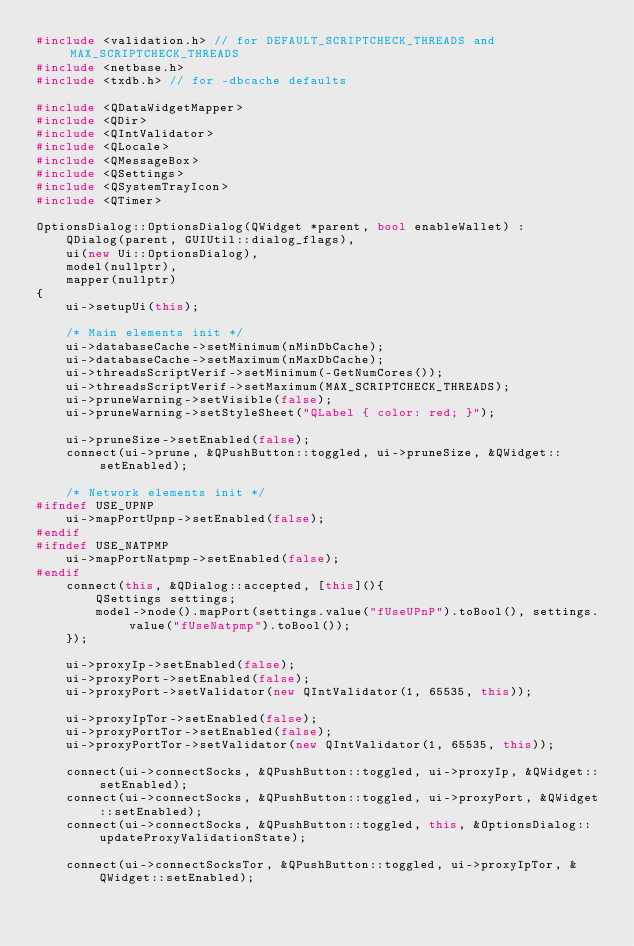<code> <loc_0><loc_0><loc_500><loc_500><_C++_>#include <validation.h> // for DEFAULT_SCRIPTCHECK_THREADS and MAX_SCRIPTCHECK_THREADS
#include <netbase.h>
#include <txdb.h> // for -dbcache defaults

#include <QDataWidgetMapper>
#include <QDir>
#include <QIntValidator>
#include <QLocale>
#include <QMessageBox>
#include <QSettings>
#include <QSystemTrayIcon>
#include <QTimer>

OptionsDialog::OptionsDialog(QWidget *parent, bool enableWallet) :
    QDialog(parent, GUIUtil::dialog_flags),
    ui(new Ui::OptionsDialog),
    model(nullptr),
    mapper(nullptr)
{
    ui->setupUi(this);

    /* Main elements init */
    ui->databaseCache->setMinimum(nMinDbCache);
    ui->databaseCache->setMaximum(nMaxDbCache);
    ui->threadsScriptVerif->setMinimum(-GetNumCores());
    ui->threadsScriptVerif->setMaximum(MAX_SCRIPTCHECK_THREADS);
    ui->pruneWarning->setVisible(false);
    ui->pruneWarning->setStyleSheet("QLabel { color: red; }");

    ui->pruneSize->setEnabled(false);
    connect(ui->prune, &QPushButton::toggled, ui->pruneSize, &QWidget::setEnabled);

    /* Network elements init */
#ifndef USE_UPNP
    ui->mapPortUpnp->setEnabled(false);
#endif
#ifndef USE_NATPMP
    ui->mapPortNatpmp->setEnabled(false);
#endif
    connect(this, &QDialog::accepted, [this](){
        QSettings settings;
        model->node().mapPort(settings.value("fUseUPnP").toBool(), settings.value("fUseNatpmp").toBool());
    });

    ui->proxyIp->setEnabled(false);
    ui->proxyPort->setEnabled(false);
    ui->proxyPort->setValidator(new QIntValidator(1, 65535, this));

    ui->proxyIpTor->setEnabled(false);
    ui->proxyPortTor->setEnabled(false);
    ui->proxyPortTor->setValidator(new QIntValidator(1, 65535, this));

    connect(ui->connectSocks, &QPushButton::toggled, ui->proxyIp, &QWidget::setEnabled);
    connect(ui->connectSocks, &QPushButton::toggled, ui->proxyPort, &QWidget::setEnabled);
    connect(ui->connectSocks, &QPushButton::toggled, this, &OptionsDialog::updateProxyValidationState);

    connect(ui->connectSocksTor, &QPushButton::toggled, ui->proxyIpTor, &QWidget::setEnabled);</code> 